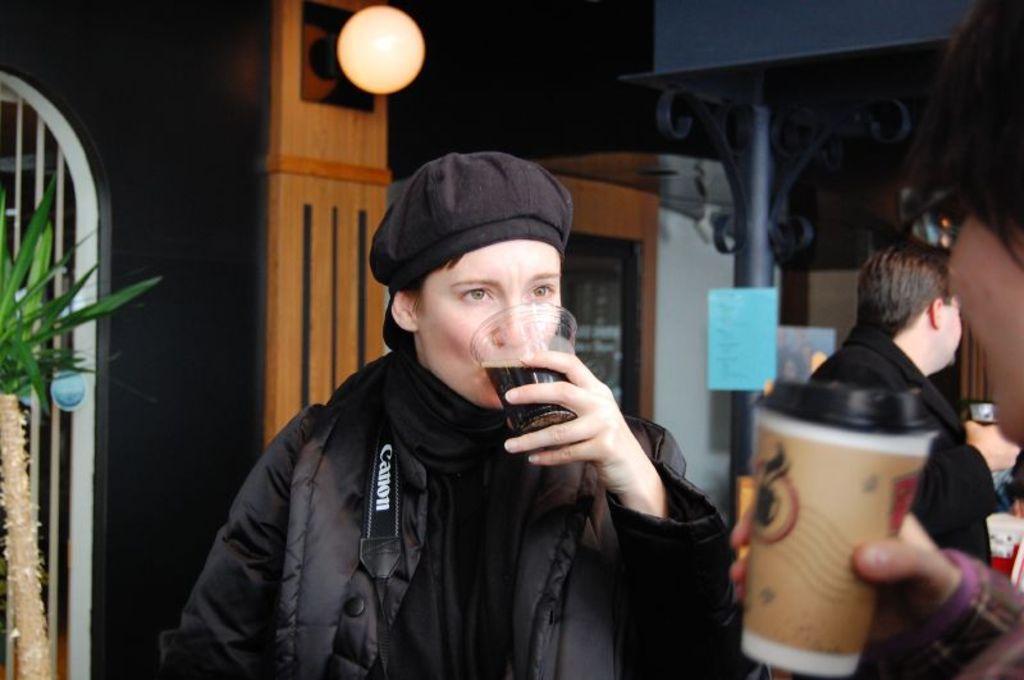In one or two sentences, can you explain what this image depicts? In this image there is a lady drinking a drink, which is in her hand in the glass, in front of her there is a person holding something, on the other side of the image there is another person holding something, above him there is a metal structure and a pepper with some text is attached, beside that there is a wooden structure with a light on it. On the left side of the image there is a plant. The background is dark. 